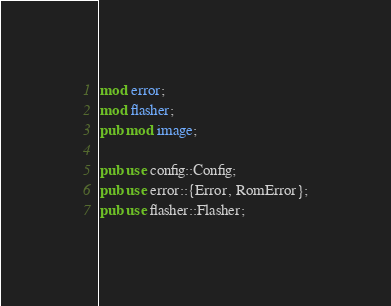<code> <loc_0><loc_0><loc_500><loc_500><_Rust_>mod error;
mod flasher;
pub mod image;

pub use config::Config;
pub use error::{Error, RomError};
pub use flasher::Flasher;
</code> 